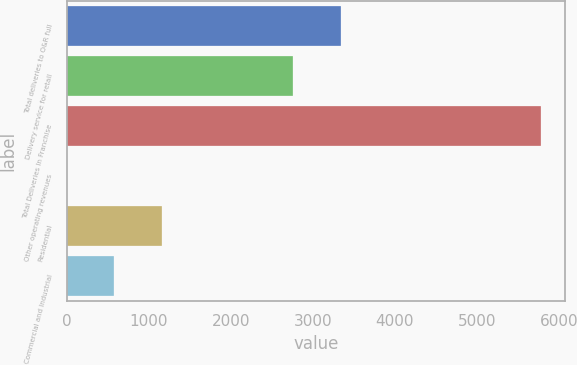Convert chart to OTSL. <chart><loc_0><loc_0><loc_500><loc_500><bar_chart><fcel>Total deliveries to O&R full<fcel>Delivery service for retail<fcel>Total Deliveries In Franchise<fcel>Other operating revenues<fcel>Residential<fcel>Commercial and Industrial<nl><fcel>3338.7<fcel>2760<fcel>5789<fcel>2<fcel>1159.4<fcel>580.7<nl></chart> 